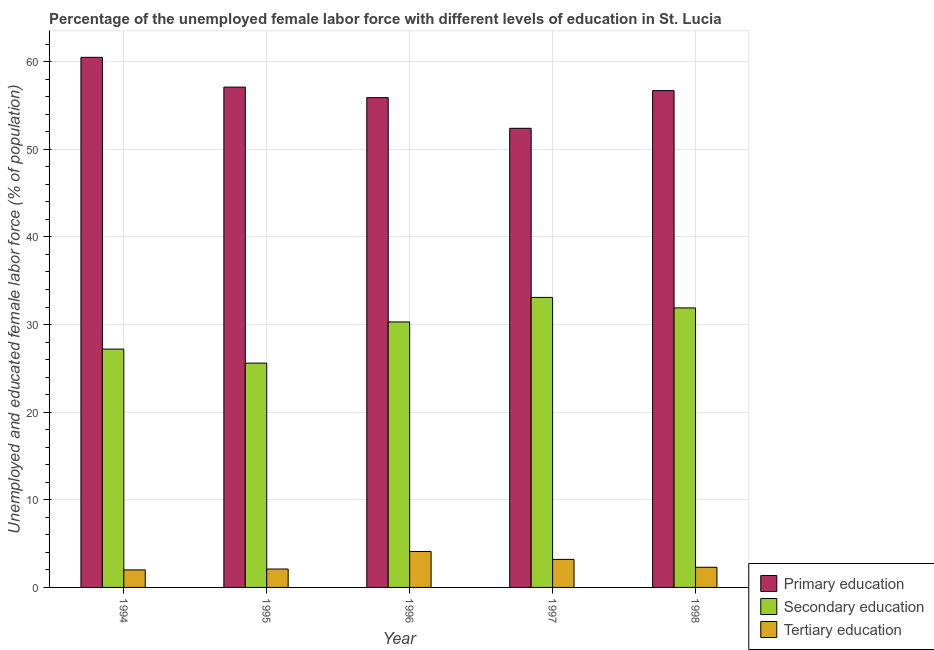How many groups of bars are there?
Your response must be concise. 5. Are the number of bars per tick equal to the number of legend labels?
Offer a very short reply. Yes. What is the label of the 4th group of bars from the left?
Provide a short and direct response. 1997. What is the percentage of female labor force who received tertiary education in 1998?
Make the answer very short. 2.3. Across all years, what is the maximum percentage of female labor force who received primary education?
Ensure brevity in your answer.  60.5. In which year was the percentage of female labor force who received primary education maximum?
Make the answer very short. 1994. What is the total percentage of female labor force who received secondary education in the graph?
Give a very brief answer. 148.1. What is the difference between the percentage of female labor force who received secondary education in 1995 and that in 1998?
Keep it short and to the point. -6.3. What is the difference between the percentage of female labor force who received tertiary education in 1997 and the percentage of female labor force who received secondary education in 1998?
Provide a short and direct response. 0.9. What is the average percentage of female labor force who received primary education per year?
Your answer should be very brief. 56.52. In how many years, is the percentage of female labor force who received secondary education greater than 14 %?
Give a very brief answer. 5. What is the ratio of the percentage of female labor force who received primary education in 1994 to that in 1998?
Your answer should be very brief. 1.07. Is the difference between the percentage of female labor force who received primary education in 1994 and 1996 greater than the difference between the percentage of female labor force who received tertiary education in 1994 and 1996?
Provide a succinct answer. No. What is the difference between the highest and the second highest percentage of female labor force who received tertiary education?
Your answer should be very brief. 0.9. What is the difference between the highest and the lowest percentage of female labor force who received primary education?
Your response must be concise. 8.1. Is the sum of the percentage of female labor force who received primary education in 1994 and 1997 greater than the maximum percentage of female labor force who received secondary education across all years?
Your response must be concise. Yes. What does the 1st bar from the left in 1998 represents?
Keep it short and to the point. Primary education. What does the 1st bar from the right in 1994 represents?
Ensure brevity in your answer.  Tertiary education. Are all the bars in the graph horizontal?
Keep it short and to the point. No. How many years are there in the graph?
Offer a terse response. 5. Are the values on the major ticks of Y-axis written in scientific E-notation?
Give a very brief answer. No. Does the graph contain grids?
Provide a succinct answer. Yes. How many legend labels are there?
Offer a very short reply. 3. How are the legend labels stacked?
Your response must be concise. Vertical. What is the title of the graph?
Offer a very short reply. Percentage of the unemployed female labor force with different levels of education in St. Lucia. What is the label or title of the X-axis?
Your answer should be compact. Year. What is the label or title of the Y-axis?
Give a very brief answer. Unemployed and educated female labor force (% of population). What is the Unemployed and educated female labor force (% of population) in Primary education in 1994?
Your answer should be compact. 60.5. What is the Unemployed and educated female labor force (% of population) of Secondary education in 1994?
Provide a succinct answer. 27.2. What is the Unemployed and educated female labor force (% of population) of Primary education in 1995?
Ensure brevity in your answer.  57.1. What is the Unemployed and educated female labor force (% of population) of Secondary education in 1995?
Keep it short and to the point. 25.6. What is the Unemployed and educated female labor force (% of population) in Tertiary education in 1995?
Ensure brevity in your answer.  2.1. What is the Unemployed and educated female labor force (% of population) in Primary education in 1996?
Offer a very short reply. 55.9. What is the Unemployed and educated female labor force (% of population) of Secondary education in 1996?
Make the answer very short. 30.3. What is the Unemployed and educated female labor force (% of population) in Tertiary education in 1996?
Offer a very short reply. 4.1. What is the Unemployed and educated female labor force (% of population) of Primary education in 1997?
Provide a short and direct response. 52.4. What is the Unemployed and educated female labor force (% of population) in Secondary education in 1997?
Keep it short and to the point. 33.1. What is the Unemployed and educated female labor force (% of population) of Tertiary education in 1997?
Provide a short and direct response. 3.2. What is the Unemployed and educated female labor force (% of population) of Primary education in 1998?
Your answer should be very brief. 56.7. What is the Unemployed and educated female labor force (% of population) of Secondary education in 1998?
Make the answer very short. 31.9. What is the Unemployed and educated female labor force (% of population) of Tertiary education in 1998?
Give a very brief answer. 2.3. Across all years, what is the maximum Unemployed and educated female labor force (% of population) in Primary education?
Provide a succinct answer. 60.5. Across all years, what is the maximum Unemployed and educated female labor force (% of population) in Secondary education?
Provide a succinct answer. 33.1. Across all years, what is the maximum Unemployed and educated female labor force (% of population) in Tertiary education?
Make the answer very short. 4.1. Across all years, what is the minimum Unemployed and educated female labor force (% of population) of Primary education?
Your answer should be compact. 52.4. Across all years, what is the minimum Unemployed and educated female labor force (% of population) of Secondary education?
Provide a succinct answer. 25.6. What is the total Unemployed and educated female labor force (% of population) in Primary education in the graph?
Make the answer very short. 282.6. What is the total Unemployed and educated female labor force (% of population) in Secondary education in the graph?
Provide a succinct answer. 148.1. What is the total Unemployed and educated female labor force (% of population) in Tertiary education in the graph?
Give a very brief answer. 13.7. What is the difference between the Unemployed and educated female labor force (% of population) of Tertiary education in 1994 and that in 1995?
Provide a succinct answer. -0.1. What is the difference between the Unemployed and educated female labor force (% of population) in Tertiary education in 1994 and that in 1996?
Your answer should be compact. -2.1. What is the difference between the Unemployed and educated female labor force (% of population) of Primary education in 1994 and that in 1997?
Ensure brevity in your answer.  8.1. What is the difference between the Unemployed and educated female labor force (% of population) in Primary education in 1994 and that in 1998?
Offer a terse response. 3.8. What is the difference between the Unemployed and educated female labor force (% of population) of Secondary education in 1995 and that in 1997?
Offer a terse response. -7.5. What is the difference between the Unemployed and educated female labor force (% of population) in Primary education in 1995 and that in 1998?
Make the answer very short. 0.4. What is the difference between the Unemployed and educated female labor force (% of population) of Secondary education in 1995 and that in 1998?
Provide a short and direct response. -6.3. What is the difference between the Unemployed and educated female labor force (% of population) in Primary education in 1996 and that in 1997?
Offer a very short reply. 3.5. What is the difference between the Unemployed and educated female labor force (% of population) in Primary education in 1996 and that in 1998?
Keep it short and to the point. -0.8. What is the difference between the Unemployed and educated female labor force (% of population) of Tertiary education in 1996 and that in 1998?
Provide a succinct answer. 1.8. What is the difference between the Unemployed and educated female labor force (% of population) of Secondary education in 1997 and that in 1998?
Ensure brevity in your answer.  1.2. What is the difference between the Unemployed and educated female labor force (% of population) in Tertiary education in 1997 and that in 1998?
Make the answer very short. 0.9. What is the difference between the Unemployed and educated female labor force (% of population) of Primary education in 1994 and the Unemployed and educated female labor force (% of population) of Secondary education in 1995?
Your answer should be compact. 34.9. What is the difference between the Unemployed and educated female labor force (% of population) in Primary education in 1994 and the Unemployed and educated female labor force (% of population) in Tertiary education in 1995?
Your answer should be very brief. 58.4. What is the difference between the Unemployed and educated female labor force (% of population) of Secondary education in 1994 and the Unemployed and educated female labor force (% of population) of Tertiary education in 1995?
Keep it short and to the point. 25.1. What is the difference between the Unemployed and educated female labor force (% of population) in Primary education in 1994 and the Unemployed and educated female labor force (% of population) in Secondary education in 1996?
Ensure brevity in your answer.  30.2. What is the difference between the Unemployed and educated female labor force (% of population) in Primary education in 1994 and the Unemployed and educated female labor force (% of population) in Tertiary education in 1996?
Offer a terse response. 56.4. What is the difference between the Unemployed and educated female labor force (% of population) in Secondary education in 1994 and the Unemployed and educated female labor force (% of population) in Tertiary education in 1996?
Provide a succinct answer. 23.1. What is the difference between the Unemployed and educated female labor force (% of population) of Primary education in 1994 and the Unemployed and educated female labor force (% of population) of Secondary education in 1997?
Your answer should be very brief. 27.4. What is the difference between the Unemployed and educated female labor force (% of population) in Primary education in 1994 and the Unemployed and educated female labor force (% of population) in Tertiary education in 1997?
Give a very brief answer. 57.3. What is the difference between the Unemployed and educated female labor force (% of population) of Secondary education in 1994 and the Unemployed and educated female labor force (% of population) of Tertiary education in 1997?
Ensure brevity in your answer.  24. What is the difference between the Unemployed and educated female labor force (% of population) in Primary education in 1994 and the Unemployed and educated female labor force (% of population) in Secondary education in 1998?
Offer a very short reply. 28.6. What is the difference between the Unemployed and educated female labor force (% of population) of Primary education in 1994 and the Unemployed and educated female labor force (% of population) of Tertiary education in 1998?
Provide a succinct answer. 58.2. What is the difference between the Unemployed and educated female labor force (% of population) of Secondary education in 1994 and the Unemployed and educated female labor force (% of population) of Tertiary education in 1998?
Offer a very short reply. 24.9. What is the difference between the Unemployed and educated female labor force (% of population) of Primary education in 1995 and the Unemployed and educated female labor force (% of population) of Secondary education in 1996?
Make the answer very short. 26.8. What is the difference between the Unemployed and educated female labor force (% of population) in Secondary education in 1995 and the Unemployed and educated female labor force (% of population) in Tertiary education in 1996?
Provide a succinct answer. 21.5. What is the difference between the Unemployed and educated female labor force (% of population) in Primary education in 1995 and the Unemployed and educated female labor force (% of population) in Secondary education in 1997?
Provide a short and direct response. 24. What is the difference between the Unemployed and educated female labor force (% of population) of Primary education in 1995 and the Unemployed and educated female labor force (% of population) of Tertiary education in 1997?
Keep it short and to the point. 53.9. What is the difference between the Unemployed and educated female labor force (% of population) of Secondary education in 1995 and the Unemployed and educated female labor force (% of population) of Tertiary education in 1997?
Your answer should be compact. 22.4. What is the difference between the Unemployed and educated female labor force (% of population) of Primary education in 1995 and the Unemployed and educated female labor force (% of population) of Secondary education in 1998?
Ensure brevity in your answer.  25.2. What is the difference between the Unemployed and educated female labor force (% of population) in Primary education in 1995 and the Unemployed and educated female labor force (% of population) in Tertiary education in 1998?
Offer a terse response. 54.8. What is the difference between the Unemployed and educated female labor force (% of population) in Secondary education in 1995 and the Unemployed and educated female labor force (% of population) in Tertiary education in 1998?
Offer a very short reply. 23.3. What is the difference between the Unemployed and educated female labor force (% of population) of Primary education in 1996 and the Unemployed and educated female labor force (% of population) of Secondary education in 1997?
Make the answer very short. 22.8. What is the difference between the Unemployed and educated female labor force (% of population) in Primary education in 1996 and the Unemployed and educated female labor force (% of population) in Tertiary education in 1997?
Keep it short and to the point. 52.7. What is the difference between the Unemployed and educated female labor force (% of population) of Secondary education in 1996 and the Unemployed and educated female labor force (% of population) of Tertiary education in 1997?
Your response must be concise. 27.1. What is the difference between the Unemployed and educated female labor force (% of population) in Primary education in 1996 and the Unemployed and educated female labor force (% of population) in Secondary education in 1998?
Offer a terse response. 24. What is the difference between the Unemployed and educated female labor force (% of population) of Primary education in 1996 and the Unemployed and educated female labor force (% of population) of Tertiary education in 1998?
Make the answer very short. 53.6. What is the difference between the Unemployed and educated female labor force (% of population) in Secondary education in 1996 and the Unemployed and educated female labor force (% of population) in Tertiary education in 1998?
Provide a short and direct response. 28. What is the difference between the Unemployed and educated female labor force (% of population) in Primary education in 1997 and the Unemployed and educated female labor force (% of population) in Tertiary education in 1998?
Your answer should be compact. 50.1. What is the difference between the Unemployed and educated female labor force (% of population) of Secondary education in 1997 and the Unemployed and educated female labor force (% of population) of Tertiary education in 1998?
Your answer should be very brief. 30.8. What is the average Unemployed and educated female labor force (% of population) of Primary education per year?
Your response must be concise. 56.52. What is the average Unemployed and educated female labor force (% of population) in Secondary education per year?
Offer a very short reply. 29.62. What is the average Unemployed and educated female labor force (% of population) in Tertiary education per year?
Make the answer very short. 2.74. In the year 1994, what is the difference between the Unemployed and educated female labor force (% of population) in Primary education and Unemployed and educated female labor force (% of population) in Secondary education?
Keep it short and to the point. 33.3. In the year 1994, what is the difference between the Unemployed and educated female labor force (% of population) of Primary education and Unemployed and educated female labor force (% of population) of Tertiary education?
Give a very brief answer. 58.5. In the year 1994, what is the difference between the Unemployed and educated female labor force (% of population) of Secondary education and Unemployed and educated female labor force (% of population) of Tertiary education?
Give a very brief answer. 25.2. In the year 1995, what is the difference between the Unemployed and educated female labor force (% of population) in Primary education and Unemployed and educated female labor force (% of population) in Secondary education?
Make the answer very short. 31.5. In the year 1996, what is the difference between the Unemployed and educated female labor force (% of population) in Primary education and Unemployed and educated female labor force (% of population) in Secondary education?
Offer a terse response. 25.6. In the year 1996, what is the difference between the Unemployed and educated female labor force (% of population) of Primary education and Unemployed and educated female labor force (% of population) of Tertiary education?
Ensure brevity in your answer.  51.8. In the year 1996, what is the difference between the Unemployed and educated female labor force (% of population) of Secondary education and Unemployed and educated female labor force (% of population) of Tertiary education?
Make the answer very short. 26.2. In the year 1997, what is the difference between the Unemployed and educated female labor force (% of population) in Primary education and Unemployed and educated female labor force (% of population) in Secondary education?
Your answer should be very brief. 19.3. In the year 1997, what is the difference between the Unemployed and educated female labor force (% of population) of Primary education and Unemployed and educated female labor force (% of population) of Tertiary education?
Ensure brevity in your answer.  49.2. In the year 1997, what is the difference between the Unemployed and educated female labor force (% of population) of Secondary education and Unemployed and educated female labor force (% of population) of Tertiary education?
Ensure brevity in your answer.  29.9. In the year 1998, what is the difference between the Unemployed and educated female labor force (% of population) of Primary education and Unemployed and educated female labor force (% of population) of Secondary education?
Your answer should be compact. 24.8. In the year 1998, what is the difference between the Unemployed and educated female labor force (% of population) in Primary education and Unemployed and educated female labor force (% of population) in Tertiary education?
Provide a short and direct response. 54.4. In the year 1998, what is the difference between the Unemployed and educated female labor force (% of population) of Secondary education and Unemployed and educated female labor force (% of population) of Tertiary education?
Ensure brevity in your answer.  29.6. What is the ratio of the Unemployed and educated female labor force (% of population) of Primary education in 1994 to that in 1995?
Make the answer very short. 1.06. What is the ratio of the Unemployed and educated female labor force (% of population) of Secondary education in 1994 to that in 1995?
Offer a terse response. 1.06. What is the ratio of the Unemployed and educated female labor force (% of population) of Primary education in 1994 to that in 1996?
Provide a succinct answer. 1.08. What is the ratio of the Unemployed and educated female labor force (% of population) of Secondary education in 1994 to that in 1996?
Offer a terse response. 0.9. What is the ratio of the Unemployed and educated female labor force (% of population) of Tertiary education in 1994 to that in 1996?
Offer a very short reply. 0.49. What is the ratio of the Unemployed and educated female labor force (% of population) in Primary education in 1994 to that in 1997?
Your response must be concise. 1.15. What is the ratio of the Unemployed and educated female labor force (% of population) of Secondary education in 1994 to that in 1997?
Give a very brief answer. 0.82. What is the ratio of the Unemployed and educated female labor force (% of population) in Tertiary education in 1994 to that in 1997?
Give a very brief answer. 0.62. What is the ratio of the Unemployed and educated female labor force (% of population) in Primary education in 1994 to that in 1998?
Provide a short and direct response. 1.07. What is the ratio of the Unemployed and educated female labor force (% of population) in Secondary education in 1994 to that in 1998?
Your answer should be very brief. 0.85. What is the ratio of the Unemployed and educated female labor force (% of population) of Tertiary education in 1994 to that in 1998?
Your answer should be compact. 0.87. What is the ratio of the Unemployed and educated female labor force (% of population) of Primary education in 1995 to that in 1996?
Make the answer very short. 1.02. What is the ratio of the Unemployed and educated female labor force (% of population) in Secondary education in 1995 to that in 1996?
Give a very brief answer. 0.84. What is the ratio of the Unemployed and educated female labor force (% of population) in Tertiary education in 1995 to that in 1996?
Ensure brevity in your answer.  0.51. What is the ratio of the Unemployed and educated female labor force (% of population) of Primary education in 1995 to that in 1997?
Offer a very short reply. 1.09. What is the ratio of the Unemployed and educated female labor force (% of population) in Secondary education in 1995 to that in 1997?
Provide a succinct answer. 0.77. What is the ratio of the Unemployed and educated female labor force (% of population) of Tertiary education in 1995 to that in 1997?
Provide a succinct answer. 0.66. What is the ratio of the Unemployed and educated female labor force (% of population) of Primary education in 1995 to that in 1998?
Make the answer very short. 1.01. What is the ratio of the Unemployed and educated female labor force (% of population) of Secondary education in 1995 to that in 1998?
Your answer should be compact. 0.8. What is the ratio of the Unemployed and educated female labor force (% of population) of Primary education in 1996 to that in 1997?
Give a very brief answer. 1.07. What is the ratio of the Unemployed and educated female labor force (% of population) of Secondary education in 1996 to that in 1997?
Your answer should be compact. 0.92. What is the ratio of the Unemployed and educated female labor force (% of population) in Tertiary education in 1996 to that in 1997?
Your answer should be compact. 1.28. What is the ratio of the Unemployed and educated female labor force (% of population) in Primary education in 1996 to that in 1998?
Give a very brief answer. 0.99. What is the ratio of the Unemployed and educated female labor force (% of population) in Secondary education in 1996 to that in 1998?
Your response must be concise. 0.95. What is the ratio of the Unemployed and educated female labor force (% of population) of Tertiary education in 1996 to that in 1998?
Your answer should be compact. 1.78. What is the ratio of the Unemployed and educated female labor force (% of population) in Primary education in 1997 to that in 1998?
Your answer should be compact. 0.92. What is the ratio of the Unemployed and educated female labor force (% of population) in Secondary education in 1997 to that in 1998?
Make the answer very short. 1.04. What is the ratio of the Unemployed and educated female labor force (% of population) of Tertiary education in 1997 to that in 1998?
Offer a very short reply. 1.39. What is the difference between the highest and the second highest Unemployed and educated female labor force (% of population) in Secondary education?
Your response must be concise. 1.2. What is the difference between the highest and the lowest Unemployed and educated female labor force (% of population) of Secondary education?
Offer a terse response. 7.5. What is the difference between the highest and the lowest Unemployed and educated female labor force (% of population) of Tertiary education?
Give a very brief answer. 2.1. 